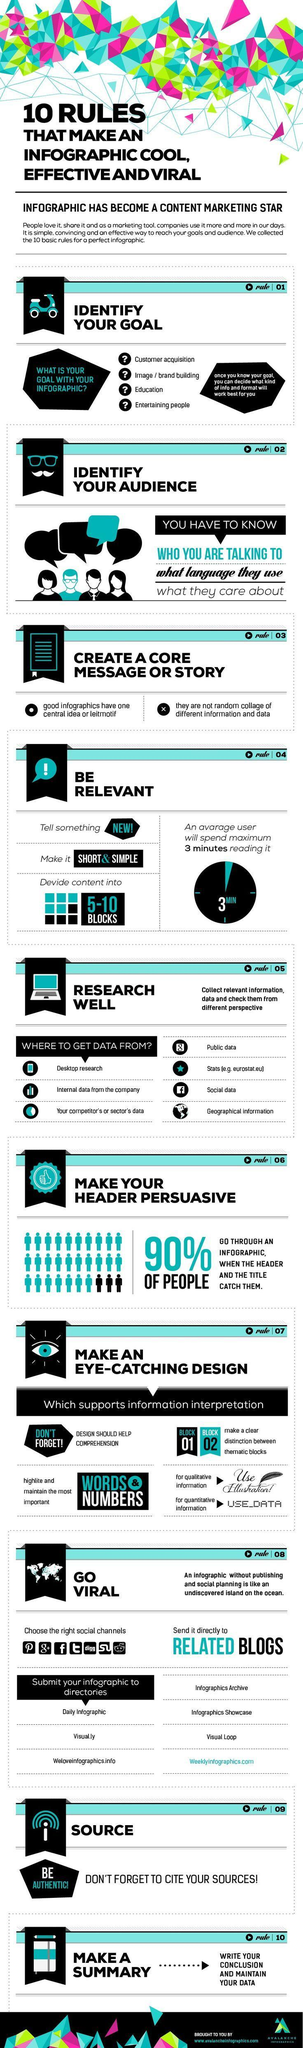How many sources can be referred to collect information?
Answer the question with a short phrase. 7 How many blocks should the infographic have, 1 block, 2 clock or 5 -10 blocks? 5 - 10 blocks What percentage of people  are unlikely to go through an infographic? 10% How many points have to be kept in mind while selecting the target audience? 3 